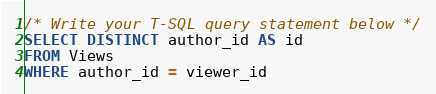<code> <loc_0><loc_0><loc_500><loc_500><_SQL_>/* Write your T-SQL query statement below */
SELECT DISTINCT author_id AS id
FROM Views
WHERE author_id = viewer_id
</code> 